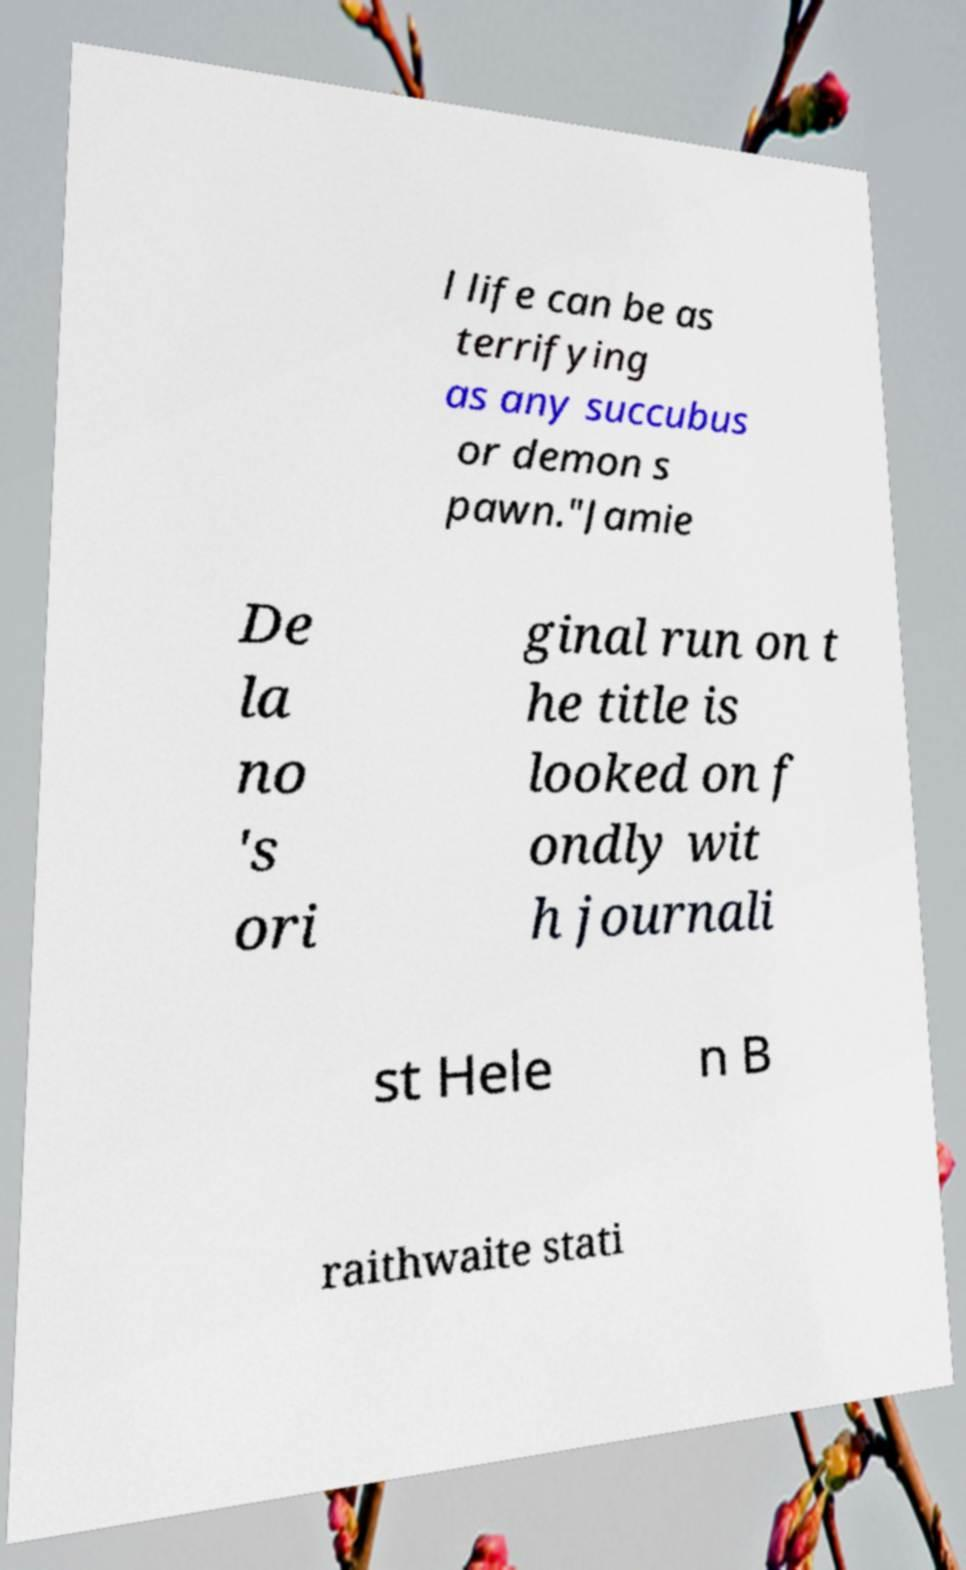There's text embedded in this image that I need extracted. Can you transcribe it verbatim? l life can be as terrifying as any succubus or demon s pawn."Jamie De la no 's ori ginal run on t he title is looked on f ondly wit h journali st Hele n B raithwaite stati 